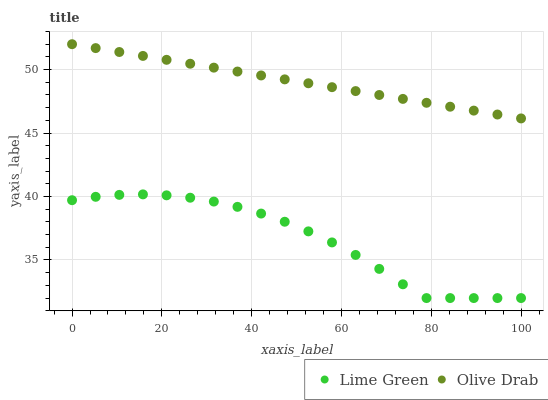Does Lime Green have the minimum area under the curve?
Answer yes or no. Yes. Does Olive Drab have the maximum area under the curve?
Answer yes or no. Yes. Does Olive Drab have the minimum area under the curve?
Answer yes or no. No. Is Olive Drab the smoothest?
Answer yes or no. Yes. Is Lime Green the roughest?
Answer yes or no. Yes. Is Olive Drab the roughest?
Answer yes or no. No. Does Lime Green have the lowest value?
Answer yes or no. Yes. Does Olive Drab have the lowest value?
Answer yes or no. No. Does Olive Drab have the highest value?
Answer yes or no. Yes. Is Lime Green less than Olive Drab?
Answer yes or no. Yes. Is Olive Drab greater than Lime Green?
Answer yes or no. Yes. Does Lime Green intersect Olive Drab?
Answer yes or no. No. 